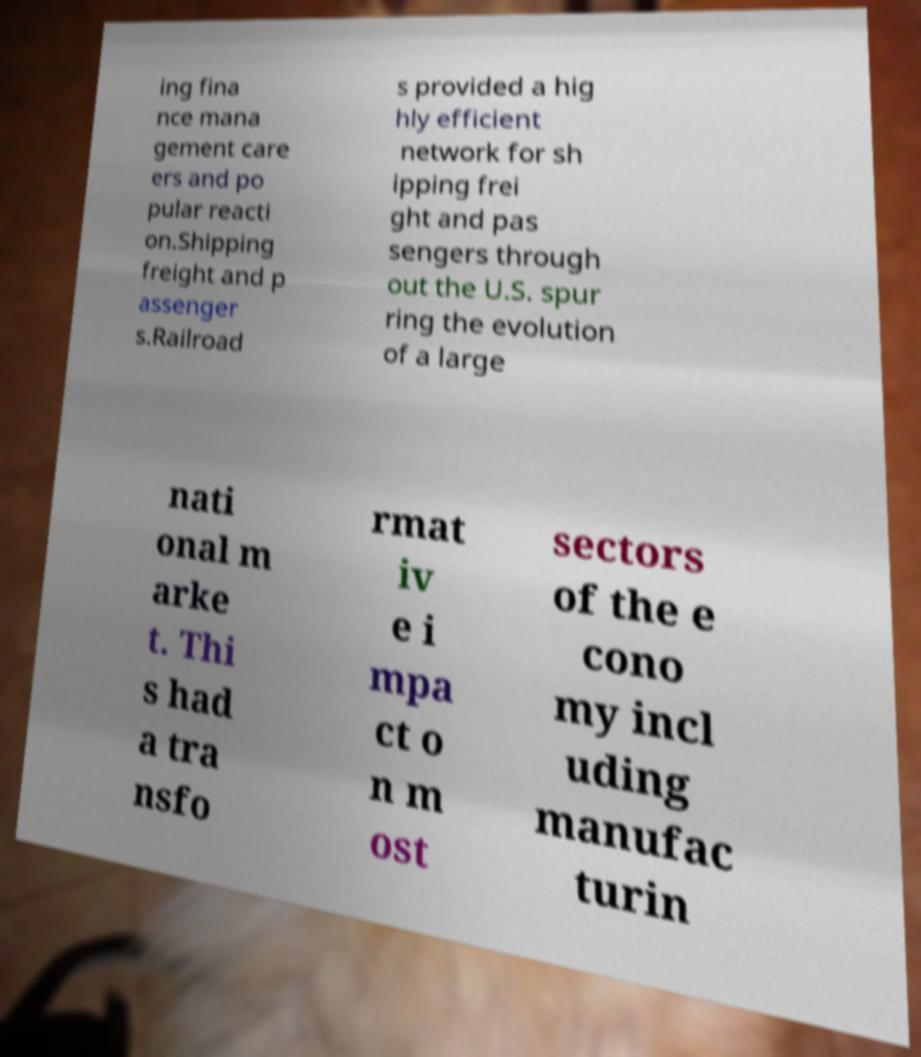I need the written content from this picture converted into text. Can you do that? ing fina nce mana gement care ers and po pular reacti on.Shipping freight and p assenger s.Railroad s provided a hig hly efficient network for sh ipping frei ght and pas sengers through out the U.S. spur ring the evolution of a large nati onal m arke t. Thi s had a tra nsfo rmat iv e i mpa ct o n m ost sectors of the e cono my incl uding manufac turin 